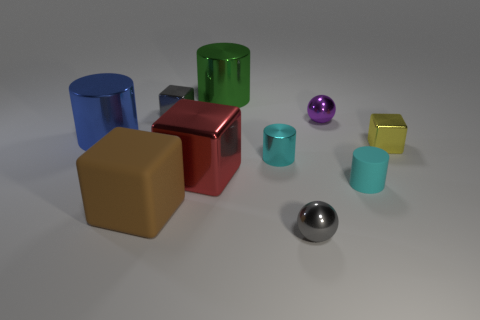Is there another tiny object of the same color as the small matte thing?
Offer a very short reply. Yes. There is a cyan rubber object that is the same size as the purple metallic ball; what is its shape?
Provide a short and direct response. Cylinder. What number of big green cylinders are to the right of the tiny sphere behind the large brown block?
Make the answer very short. 0. Does the tiny matte cylinder have the same color as the big rubber cube?
Make the answer very short. No. What number of other things are made of the same material as the red cube?
Provide a short and direct response. 7. The large shiny thing in front of the metal cylinder that is on the left side of the brown rubber thing is what shape?
Keep it short and to the point. Cube. How big is the shiny cube that is behind the small yellow metal thing?
Provide a short and direct response. Small. Are the red block and the big blue cylinder made of the same material?
Provide a succinct answer. Yes. What is the shape of the small cyan object that is made of the same material as the large blue cylinder?
Your answer should be very brief. Cylinder. Are there any other things of the same color as the tiny matte thing?
Offer a terse response. Yes. 